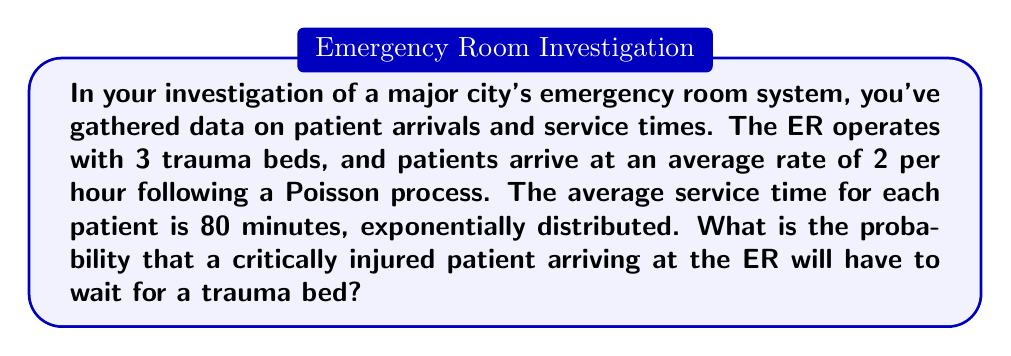Can you answer this question? To solve this problem, we'll use the M/M/c queueing model, where M/M denotes Markovian arrival and service processes, and c is the number of servers (trauma beds in this case).

Step 1: Identify the parameters
- Arrival rate: $\lambda = 2$ patients/hour
- Service rate: $\mu = \frac{60 \text{ min/hour}}{80 \text{ min/patient}} = 0.75$ patients/hour
- Number of servers: $c = 3$ trauma beds

Step 2: Calculate the utilization factor $\rho$
$$\rho = \frac{\lambda}{c\mu} = \frac{2}{3 \cdot 0.75} = \frac{8}{9} \approx 0.889$$

Step 3: Calculate $P_0$, the probability of an empty system
$$P_0 = \left[\sum_{n=0}^{c-1}\frac{(c\rho)^n}{n!} + \frac{(c\rho)^c}{c!(1-\rho)}\right]^{-1}$$

$$P_0 = \left[1 + \frac{8}{3} + \frac{32}{9} + \frac{512}{81(1-8/9)}\right]^{-1} \approx 0.0230$$

Step 4: Calculate $P_w$, the probability of waiting
$$P_w = \frac{(c\rho)^c}{c!(1-\rho)} P_0$$

$$P_w = \frac{(3 \cdot 8/9)^3}{3!(1-8/9)} \cdot 0.0230 \approx 0.5957$$

Therefore, the probability that a critically injured patient will have to wait for a trauma bed is approximately 0.5957 or 59.57%.
Answer: 0.5957 